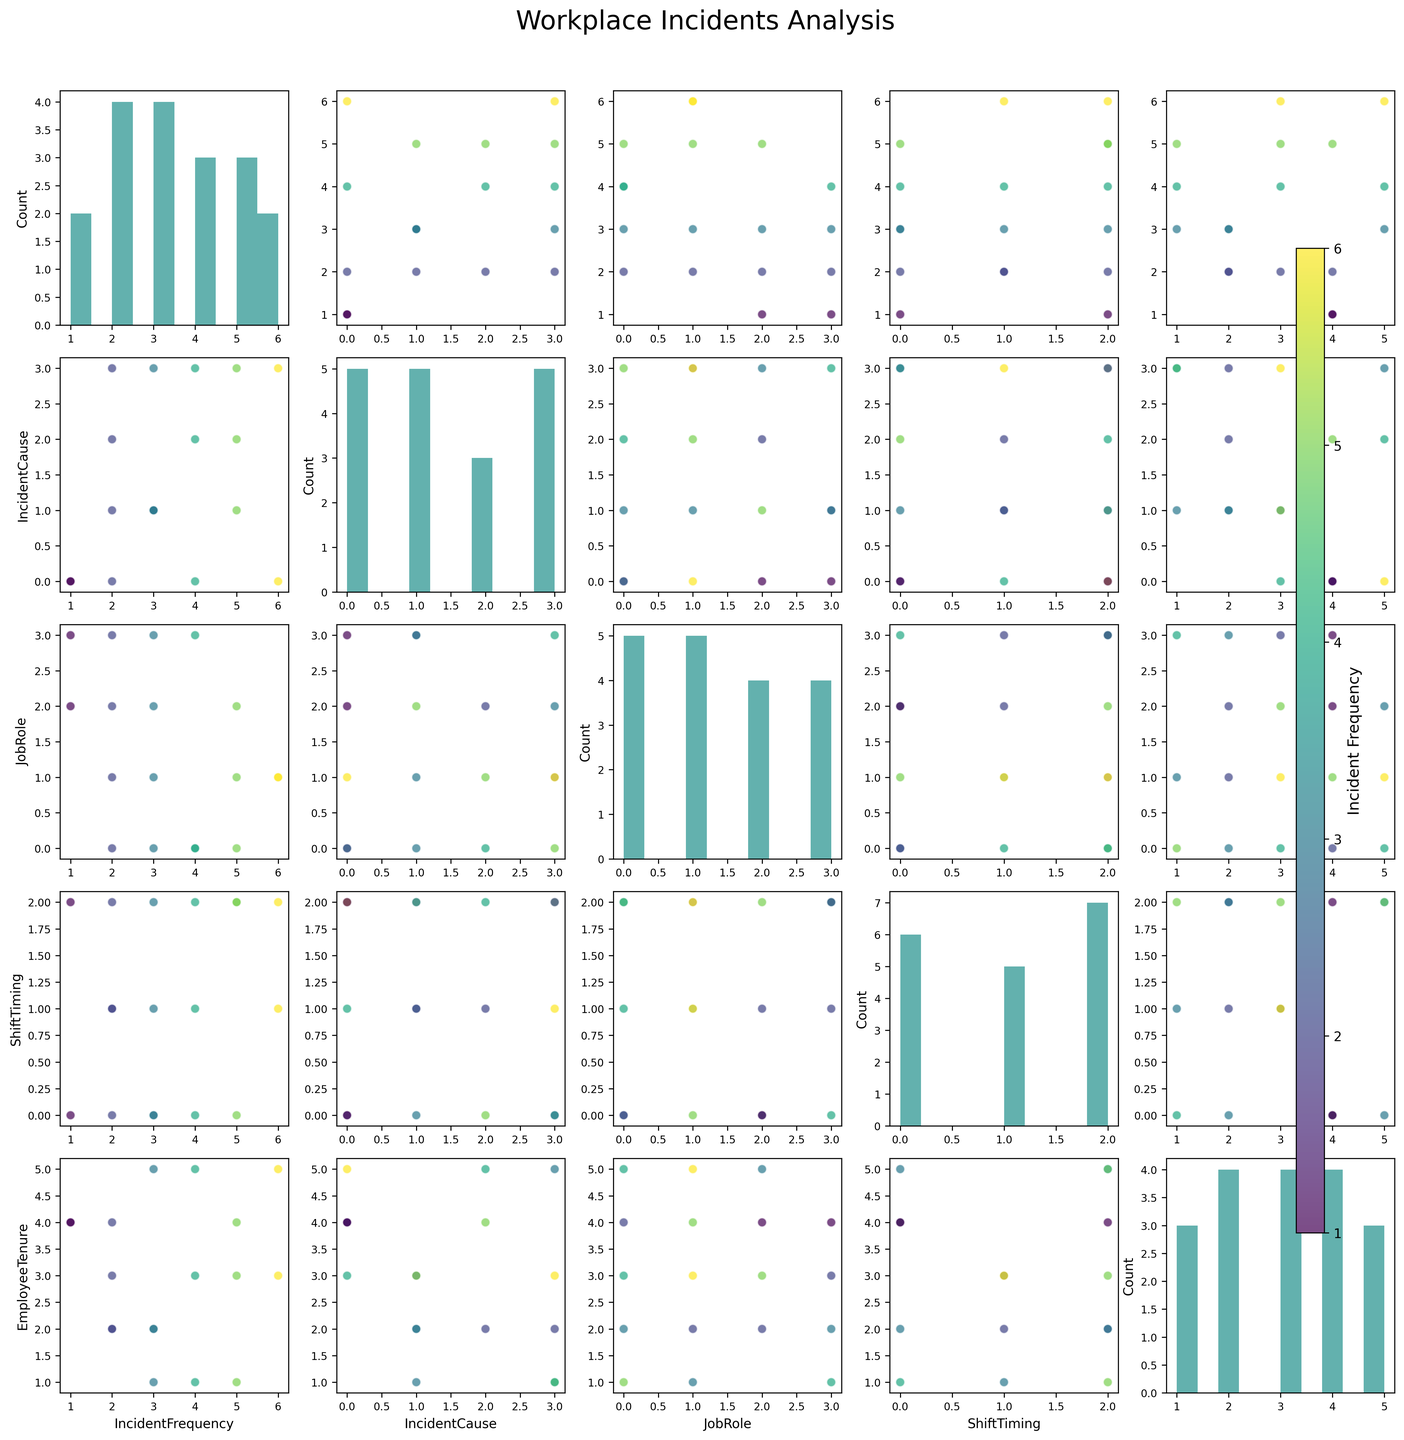What is the title of the figure? The title is located at the top of the figure, generally in the center.
Answer: "Workplace Incidents Analysis" How are the values color-coded in the scatter plots? The color coding is based on the 'Incident Frequency' variable. This can be inferred from the color bar on the right side of the figure. The color changes indicating different frequencies of incidents.
Answer: Incident Frequency Which variable seems to be represented on the x-axis of the bottom row of scatter plots? By following the last row horizontally, we can see the variable name at the bottom of each scatter plot.
Answer: Employee Tenure How many bars are present in the histogram for 'Job Role'? The histogram for any variable, like 'Job Role,' is located in a diagonal position of this matrix figure. By counting the bars, we get the answer.
Answer: 4 Which shift timing has the highest incident frequency for Dishwashers? To identify this, we look at the scatter plot with 'Shift Timing' on the x-axis and filter points where 'Job Role' indicates Dishwasher. We then check the corresponding 'Incident Frequency' for each shift.
Answer: Night Who experiences more Equipment Fault incidents: Line Cooks or Servers? We need to look at the points where the 'Incident Cause' is Equipment Fault and compare the number of incidents for 'Line Cooks' and 'Servers'.
Answer: Line Cooks Is there a pattern visible between 'Incident Frequency' and 'Employee Tenure'? Look at the scatter plot where 'Incident Frequency' is one axis and 'Employee Tenure' is the other. Observe any patterns or trends, positive or negative.
Answer: No clear pattern What combination of 'Job Role' and 'Shift Timing' results in the highest 'Incident Frequency'? Look through the scatter plots to find the combination of 'Job Role' and 'Shift Timing' with the highest incident count. Typically, this involves checking the color intensity corresponding to the highest value.
Answer: Line Cook, Night Do evening shifts show more slip and fall incidents compared to chemical exposure incidents? Compare the scatter plots with 'Shift Timing' on the x-axis and identify the points where 'Shift Timing' is evening. Count and compare the number of points colored according to 'SlipAndFall' and 'ChemicalExposure'.
Answer: More Slip and Fall Incidents Summarize the highest and lowest frequencies of burn incidents across different job roles. By looking at scatter plots where the cause is 'Burn,' identify the maximum and minimum frequencies of burn incidents and the associated job roles.
Answer: Highest: Line Cook (6); Lowest: Server (1) 